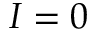Convert formula to latex. <formula><loc_0><loc_0><loc_500><loc_500>I = 0</formula> 